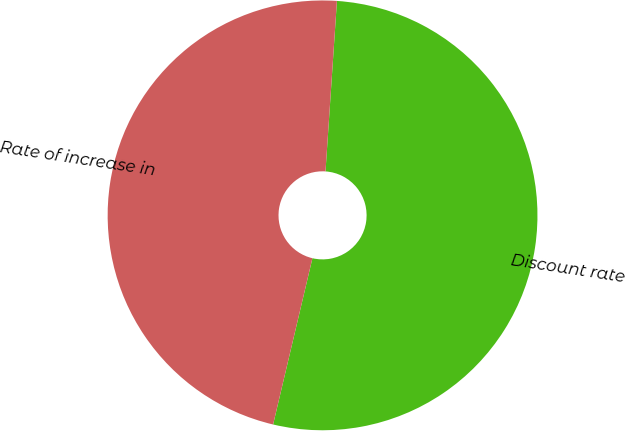<chart> <loc_0><loc_0><loc_500><loc_500><pie_chart><fcel>Discount rate<fcel>Rate of increase in<nl><fcel>52.63%<fcel>47.37%<nl></chart> 